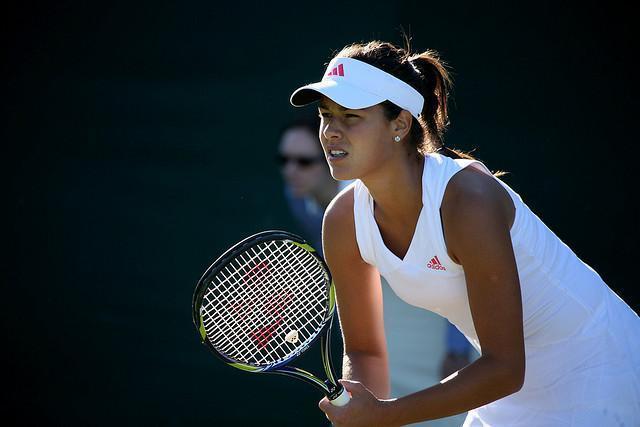How many hands is the player using to hold the racket?
Give a very brief answer. 2. How many people are in the picture?
Give a very brief answer. 2. How many cars are in this picture?
Give a very brief answer. 0. 